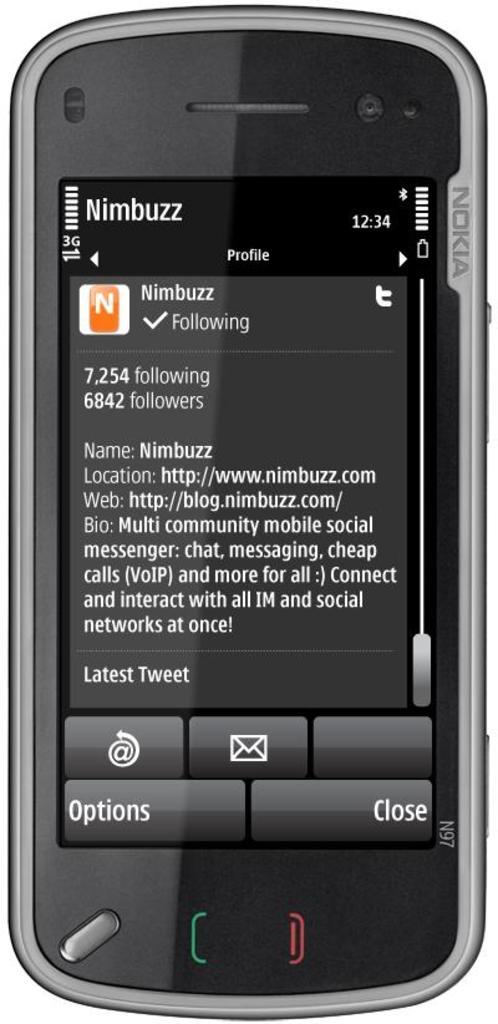<image>
Create a compact narrative representing the image presented. A Nokia phone shows a profile for a user Nimbuzz. 